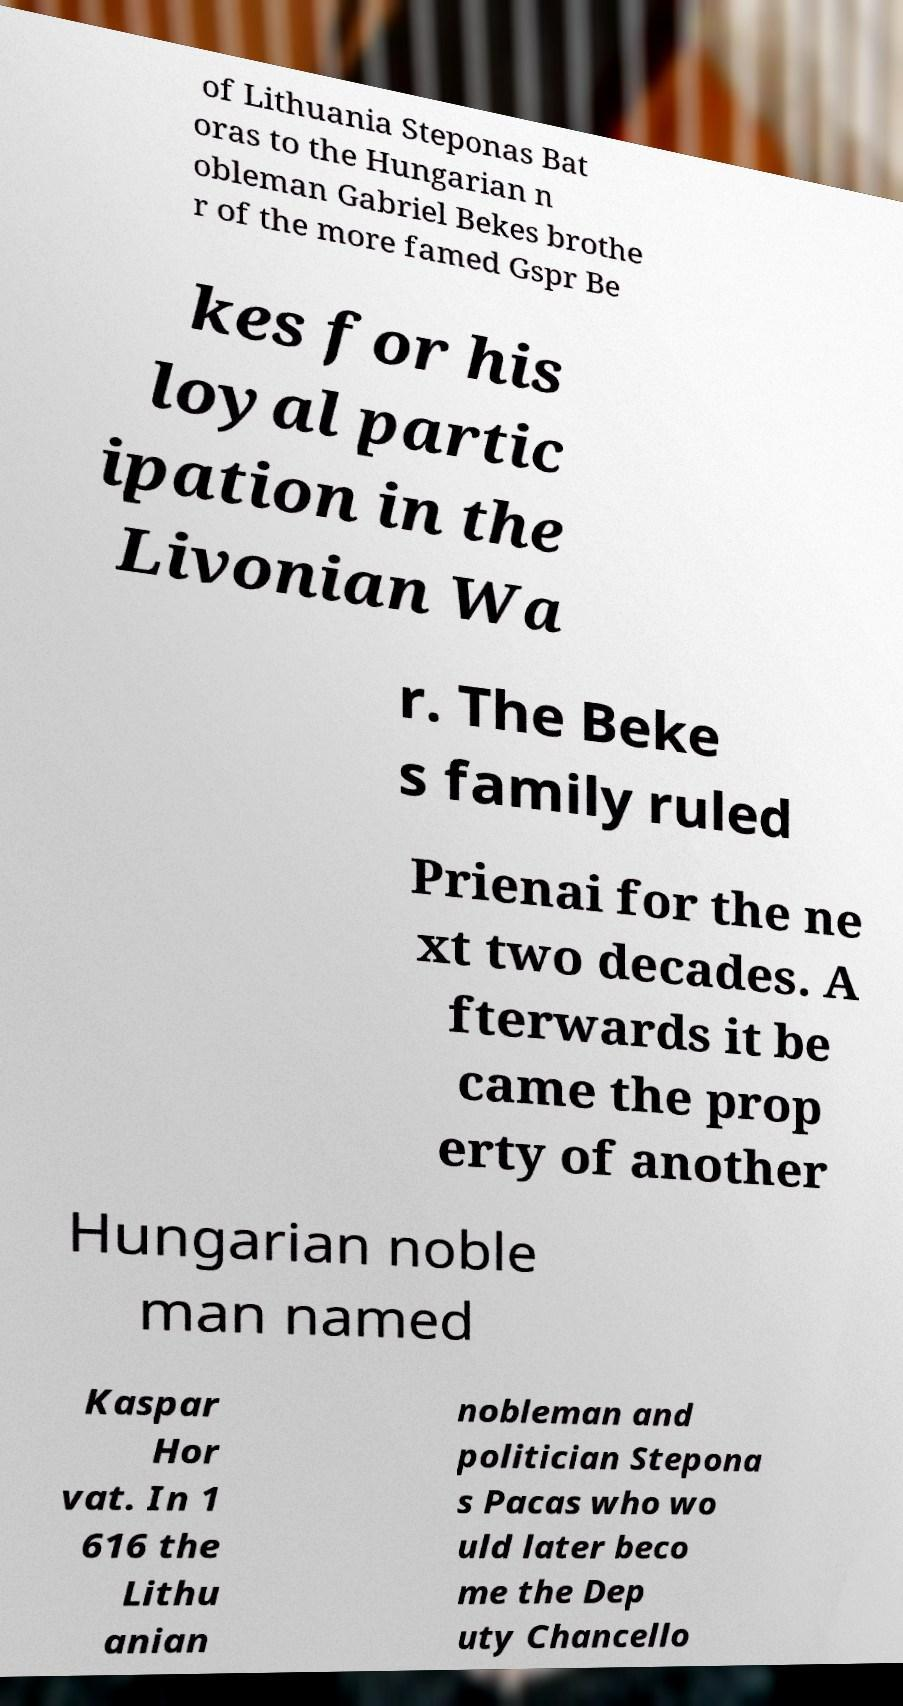What messages or text are displayed in this image? I need them in a readable, typed format. of Lithuania Steponas Bat oras to the Hungarian n obleman Gabriel Bekes brothe r of the more famed Gspr Be kes for his loyal partic ipation in the Livonian Wa r. The Beke s family ruled Prienai for the ne xt two decades. A fterwards it be came the prop erty of another Hungarian noble man named Kaspar Hor vat. In 1 616 the Lithu anian nobleman and politician Stepona s Pacas who wo uld later beco me the Dep uty Chancello 